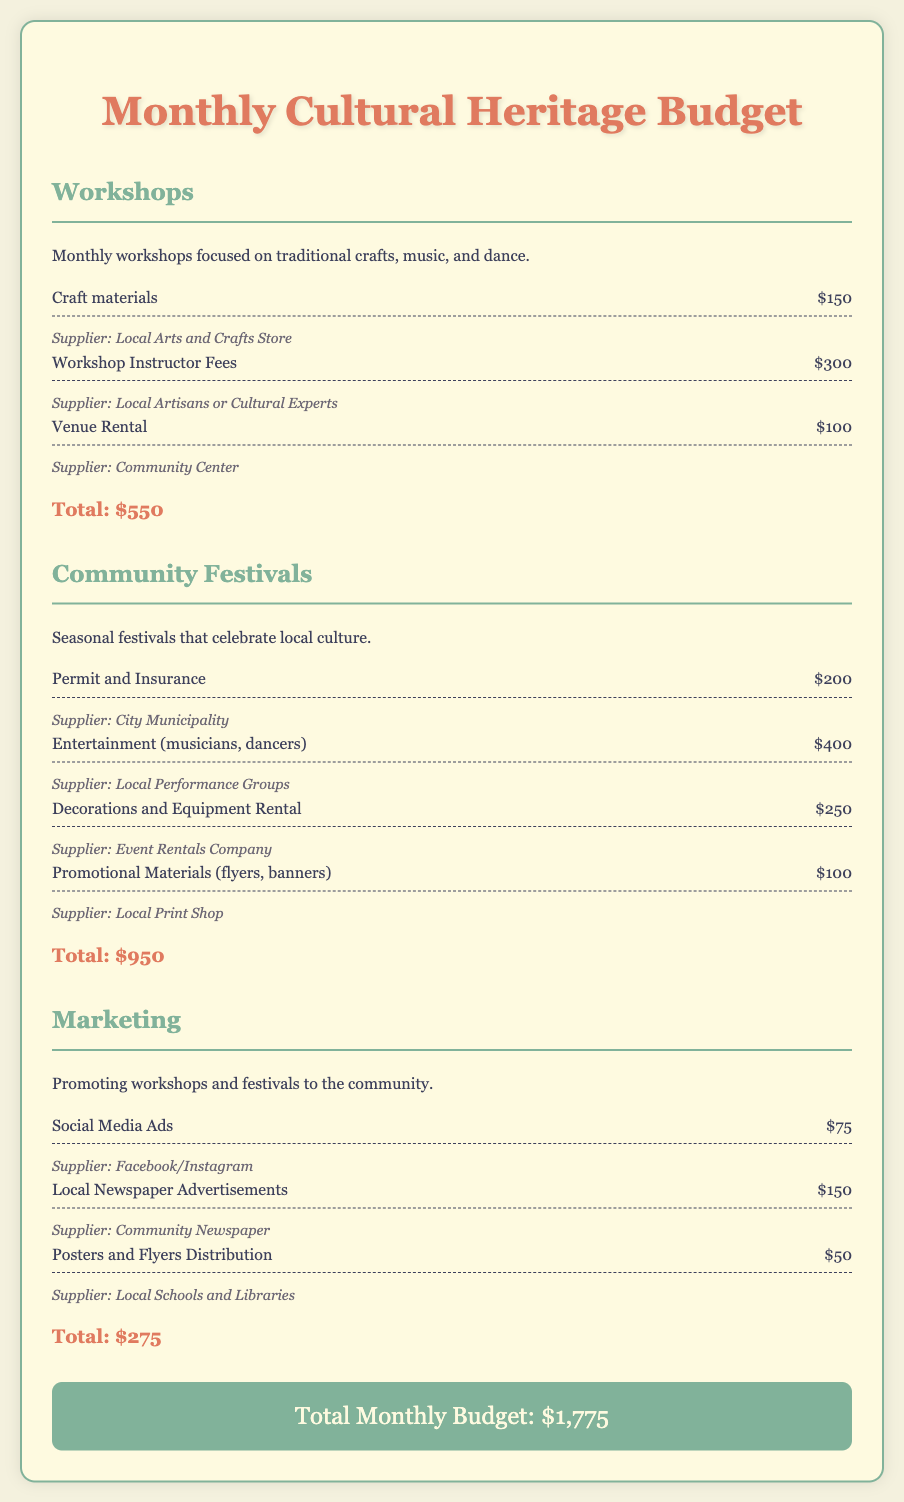what is the total budget for workshops? The total budget for workshops is detailed in the document under the Workshops section, which shows a total of $550.
Answer: $550 what is the cost for promotional materials? The cost for promotional materials in the Community Festivals section is specified as $100.
Answer: $100 who supplies the craft materials? The document lists the Local Arts and Crafts Store as the supplier for craft materials in the Workshops section.
Answer: Local Arts and Crafts Store how much is allocated for social media ads? The budget item for social media ads is stated to be $75 in the Marketing section.
Answer: $75 what is the total cost for community festivals? The total amount for community festivals, calculated based on the listed expenses, comes to $950.
Answer: $950 how much is the grand total for the monthly budget? The grand total for the monthly budget is presented at the end of the document and amounts to $1,775.
Answer: $1,775 which section has the highest budget? By comparing the totals in each section, the Community Festivals section has the highest budget at $950.
Answer: Community Festivals what are the workshop instructor fees? The document specifies the workshop instructor fees as $300 under the Workshops section.
Answer: $300 is there a line item for decorations in the document? Yes, the document includes a line item for decorations and equipment rental, costing $250 in the Community Festivals section.
Answer: $250 